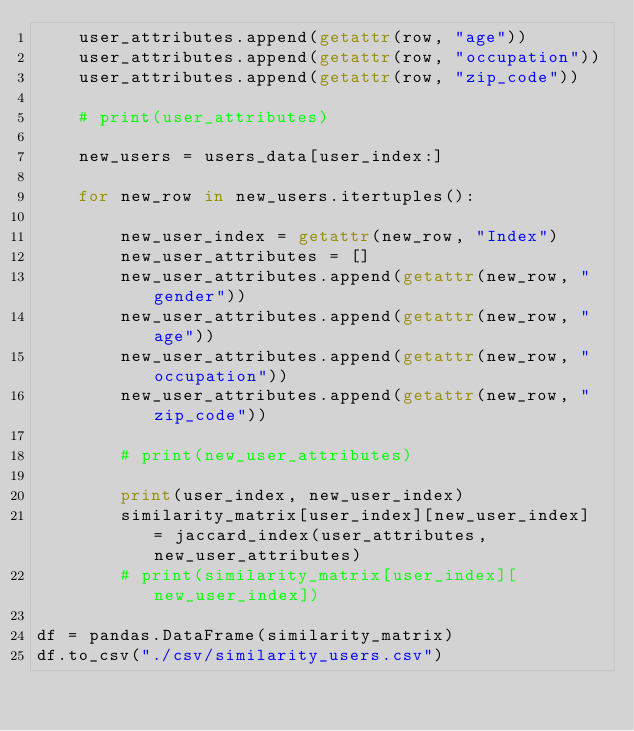<code> <loc_0><loc_0><loc_500><loc_500><_Python_>    user_attributes.append(getattr(row, "age"))
    user_attributes.append(getattr(row, "occupation"))
    user_attributes.append(getattr(row, "zip_code"))

    # print(user_attributes)
    
    new_users = users_data[user_index:]

    for new_row in new_users.itertuples():
        
        new_user_index = getattr(new_row, "Index")
        new_user_attributes = []
        new_user_attributes.append(getattr(new_row, "gender"))
        new_user_attributes.append(getattr(new_row, "age"))
        new_user_attributes.append(getattr(new_row, "occupation"))
        new_user_attributes.append(getattr(new_row, "zip_code"))

        # print(new_user_attributes)

        print(user_index, new_user_index)
        similarity_matrix[user_index][new_user_index] = jaccard_index(user_attributes, new_user_attributes)
        # print(similarity_matrix[user_index][new_user_index])

df = pandas.DataFrame(similarity_matrix)
df.to_csv("./csv/similarity_users.csv")
    </code> 